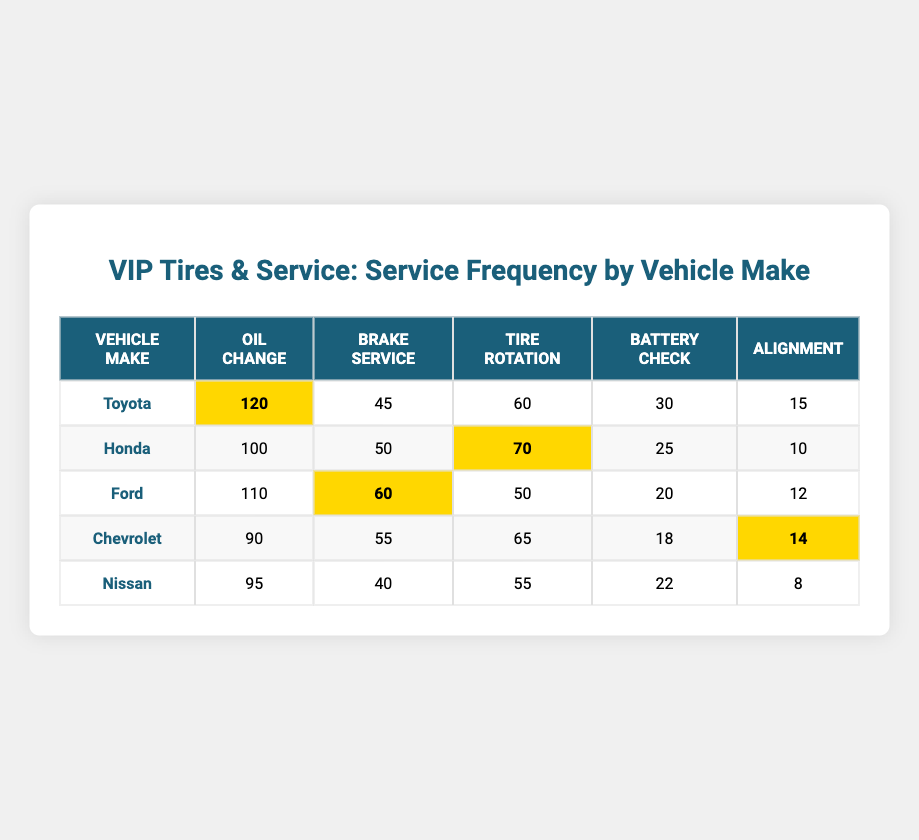What vehicle make had the highest number of oil changes? By looking at the table, the "Oil Change" column shows that Toyota has the highest frequency with 120 services recorded.
Answer: Toyota Which vehicle make had the least frequency for battery checks? The "Battery Check" column indicates that Nissan had the least frequency, with a count of 22 in that category.
Answer: Nissan What is the total number of tire rotations for all vehicle makes combined? To find the total number of tire rotations, I sum the values across the "Tire Rotation" column: 60 + 70 + 50 + 65 + 55 = 310.
Answer: 310 For which vehicle make is brake service frequency higher than battery check frequency? By comparing the "Brake Service" and "Battery Check" columns, both Ford (60 vs. 20) and Toyota (45 vs. 30) have higher brake service frequencies than battery checks.
Answer: Ford and Toyota Is the average frequency of oil change services greater than 100 across all vehicle makes? First, I identify the oil change frequencies: 120, 100, 110, 90, 95. Summing these gives 515. Then I divide by the number of vehicle makes (5): 515 / 5 = 103. Thus, the average is indeed greater than 100.
Answer: Yes Which service type saw the maximum frequency for Chevrolet? Looking at the Chevrolet row in the table, the "Tire Rotation" service frequency is the highest, with a count of 65.
Answer: Tire Rotation What is the difference between the highest and lowest frequency of alignment services? The highest alignment frequency is 15 (Toyota), and the lowest is 8 (Nissan). The difference is 15 - 8 = 7.
Answer: 7 Which vehicle make had equal or greater than 60 for brake service? Ford (60), Chevrolet (55), Toyota (45), and Honda (50) are all below 60 except for Ford, which meets the criteria. Thus, only Ford counts here.
Answer: Ford Is Honda the only vehicle make with more than 100 oil changes? The oil change frequencies show that Toyota (120) and Ford (110) also exceed 100, so Honda is not the only one.
Answer: No 